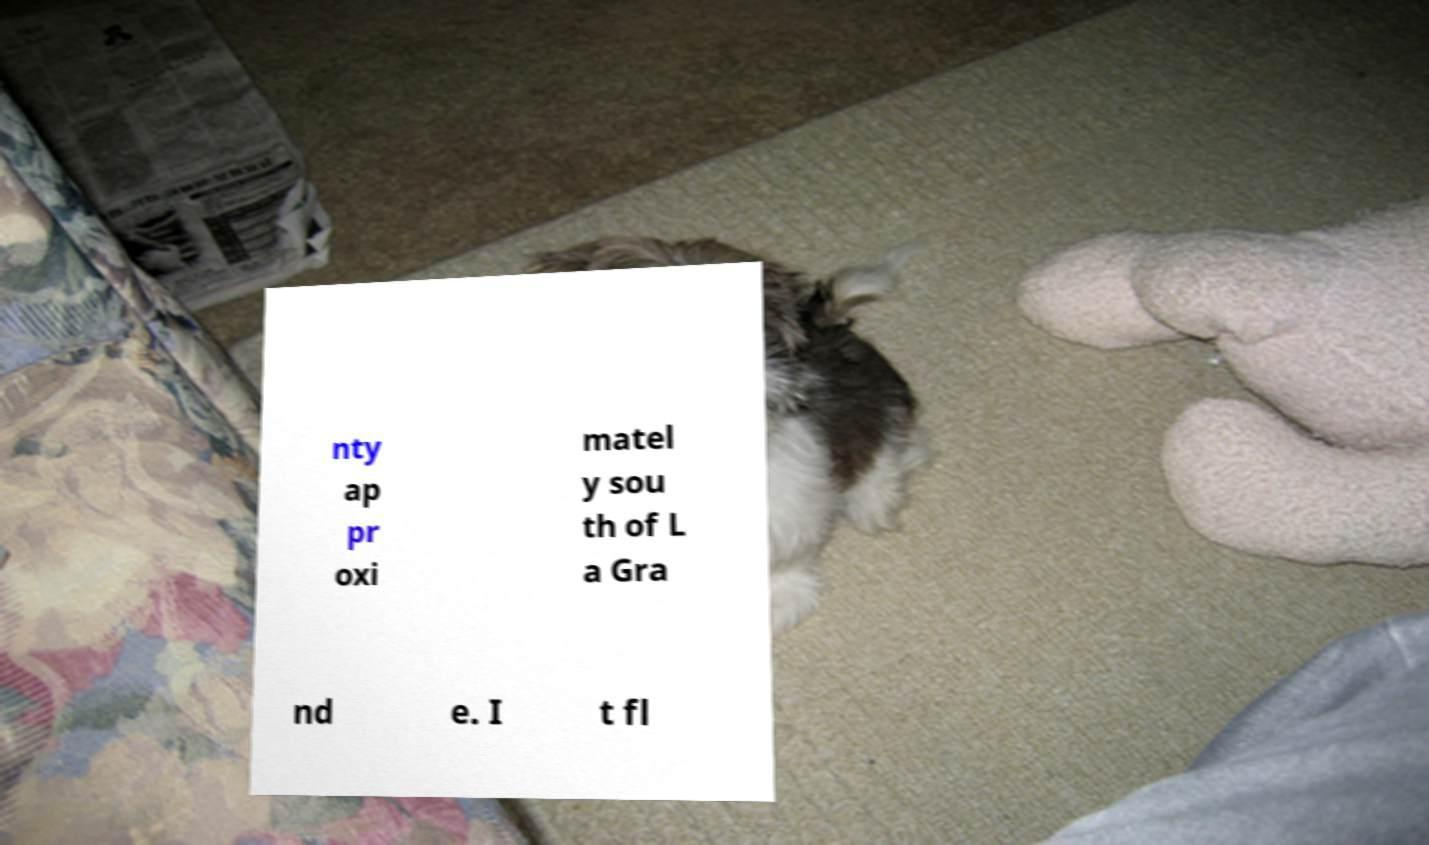Please identify and transcribe the text found in this image. nty ap pr oxi matel y sou th of L a Gra nd e. I t fl 